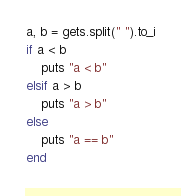Convert code to text. <code><loc_0><loc_0><loc_500><loc_500><_Ruby_>a, b = gets.split(" ").to_i
if a < b
    puts "a < b"
elsif a > b
    puts "a > b"
else
    puts "a == b"
end</code> 